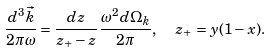Convert formula to latex. <formula><loc_0><loc_0><loc_500><loc_500>\frac { d ^ { 3 } { \vec { k } } } { 2 \pi \omega } = \frac { d z } { z _ { + } - z } \frac { \omega ^ { 2 } d \Omega _ { k } } { 2 \pi } , \ \ z _ { + } = y ( 1 - x ) .</formula> 